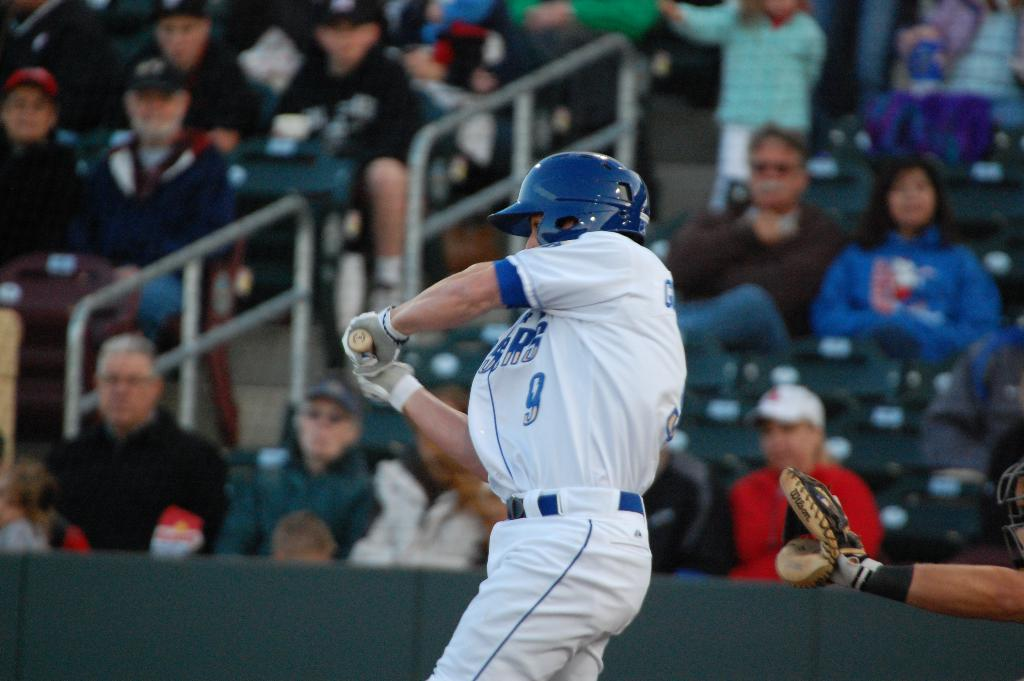<image>
Relay a brief, clear account of the picture shown. Player number 9 is mid-swing during his turn at bat. 